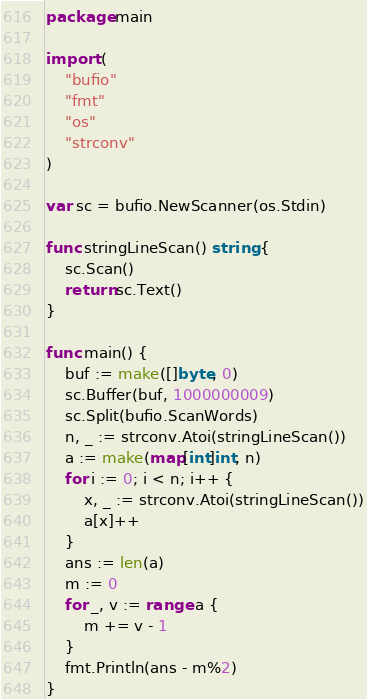Convert code to text. <code><loc_0><loc_0><loc_500><loc_500><_Go_>package main

import (
	"bufio"
	"fmt"
	"os"
	"strconv"
)

var sc = bufio.NewScanner(os.Stdin)

func stringLineScan() string {
	sc.Scan()
	return sc.Text()
}

func main() {
	buf := make([]byte, 0)
	sc.Buffer(buf, 1000000009)
	sc.Split(bufio.ScanWords)
	n, _ := strconv.Atoi(stringLineScan())
	a := make(map[int]int, n)
	for i := 0; i < n; i++ {
		x, _ := strconv.Atoi(stringLineScan())
		a[x]++
	}
	ans := len(a)
	m := 0
	for _, v := range a {
		m += v - 1
	}
	fmt.Println(ans - m%2)
}</code> 